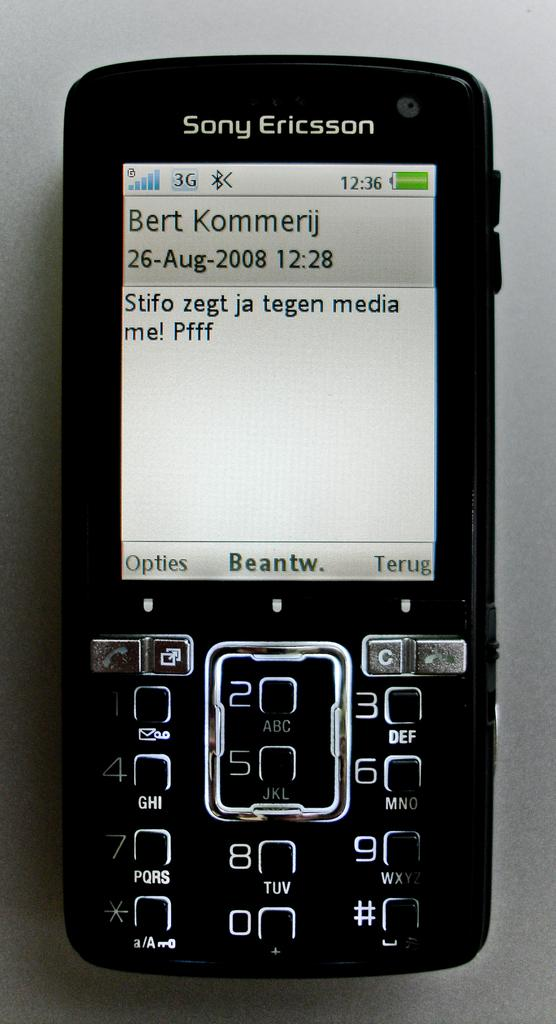<image>
Write a terse but informative summary of the picture. An older Sony Ericsson phone with a text from Bert Kommerij on it in a foreign language. 